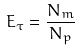Convert formula to latex. <formula><loc_0><loc_0><loc_500><loc_500>E _ { \tau } = \frac { N _ { m } } { N _ { p } }</formula> 